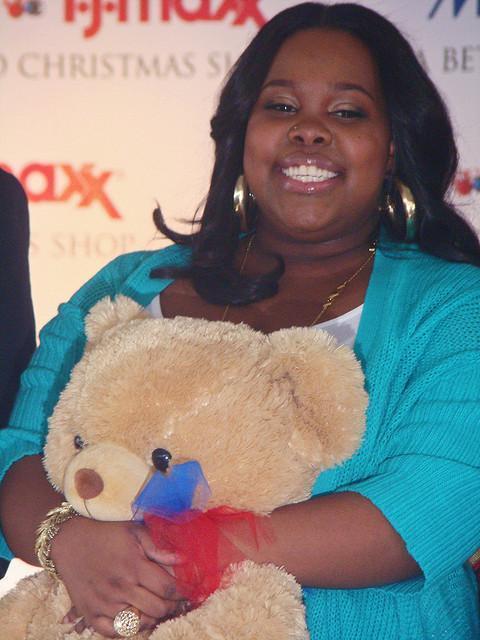How many red color pizza on the bowl?
Give a very brief answer. 0. 